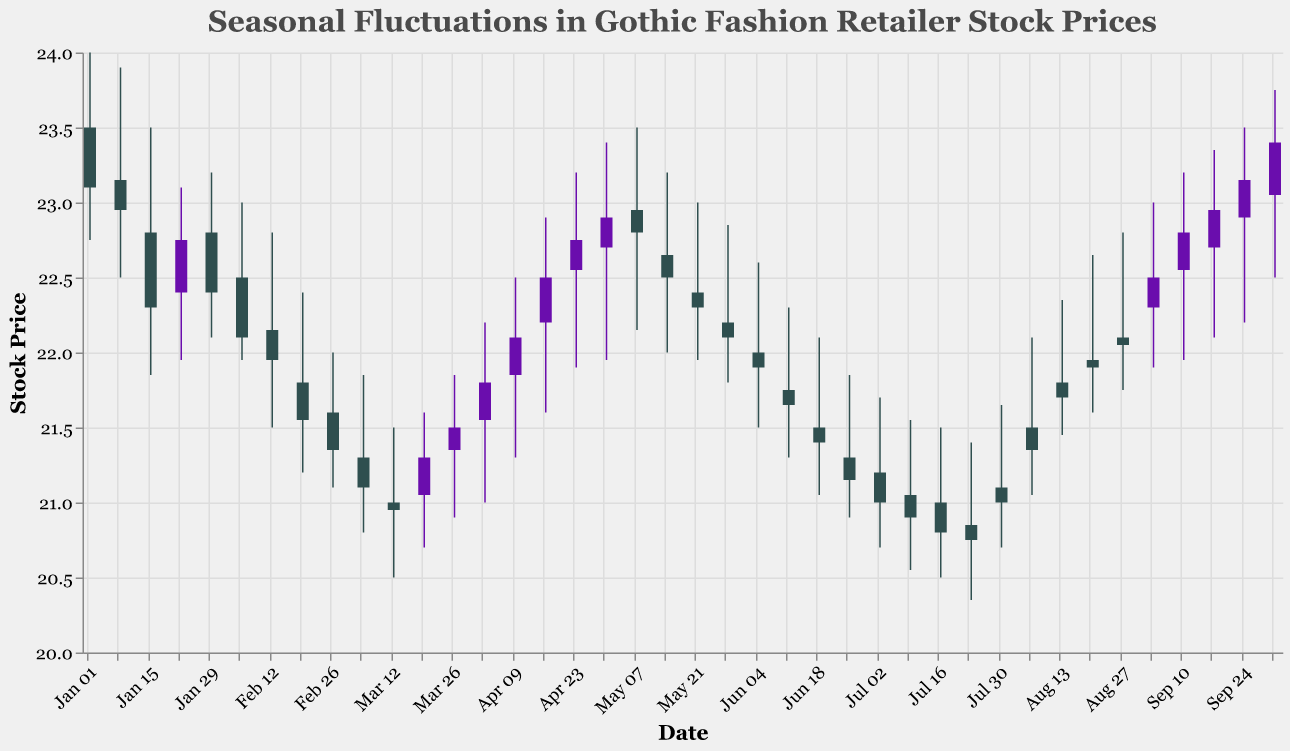What is the highest stock price recorded in the given period? The highest stock price is indicated by the peak of 'High' values in the candlestick chart. The highest 'High' value is 24.00 on 2023-01-02.
Answer: 24.00 Which month shows the lowest closing stock price? To find the lowest closing price, identify the lowest value on the 'Close' axis for each month. The lowest closing price is 20.75 recorded in July.
Answer: July From the provided data, which week shows a notable price drop compared to the previous week? A notable price drop can be observed by calculating the difference in closing prices from one week to the next. The most significant week-to-week drop occurred between 2023-01-02 and 2023-01-09, where the closing price fell from 23.10 to 22.95.
Answer: 2023-01-09 Is there a general trend in stock prices from January to October? Examine the overall pattern of the ‘Close’ prices from January to October. The prices generally increase slightly and then undergo a noticeable dip around mid-year before recovering toward the end.
Answer: Dipped mid-year and recovered Which period experiences the most volatility based on the difference between high and low values? Volatility is indicated by the difference between 'High' and 'Low' values. The largest difference is seen on 2023-01-02 with a range of 24.00 - 22.75 = 1.25.
Answer: 2023-01-02 What is the average closing price for August? Average closing price can be calculated by summing the weekly closing prices in August and then dividing by the number of weeks. The closing prices are 21.35, 21.70, 21.90, and 22.05. Sum = 87.00, Number of weeks = 4. Average = 87.00 / 4 = 21.75
Answer: 21.75 How do the opening prices in September compare to those in January? Compare the opening prices listed for each week in January and September. In January, the opening prices range from 22.40 to 23.50, while in September they range from 22.30 to 22.90. January's openings are generally higher.
Answer: January openings are higher 